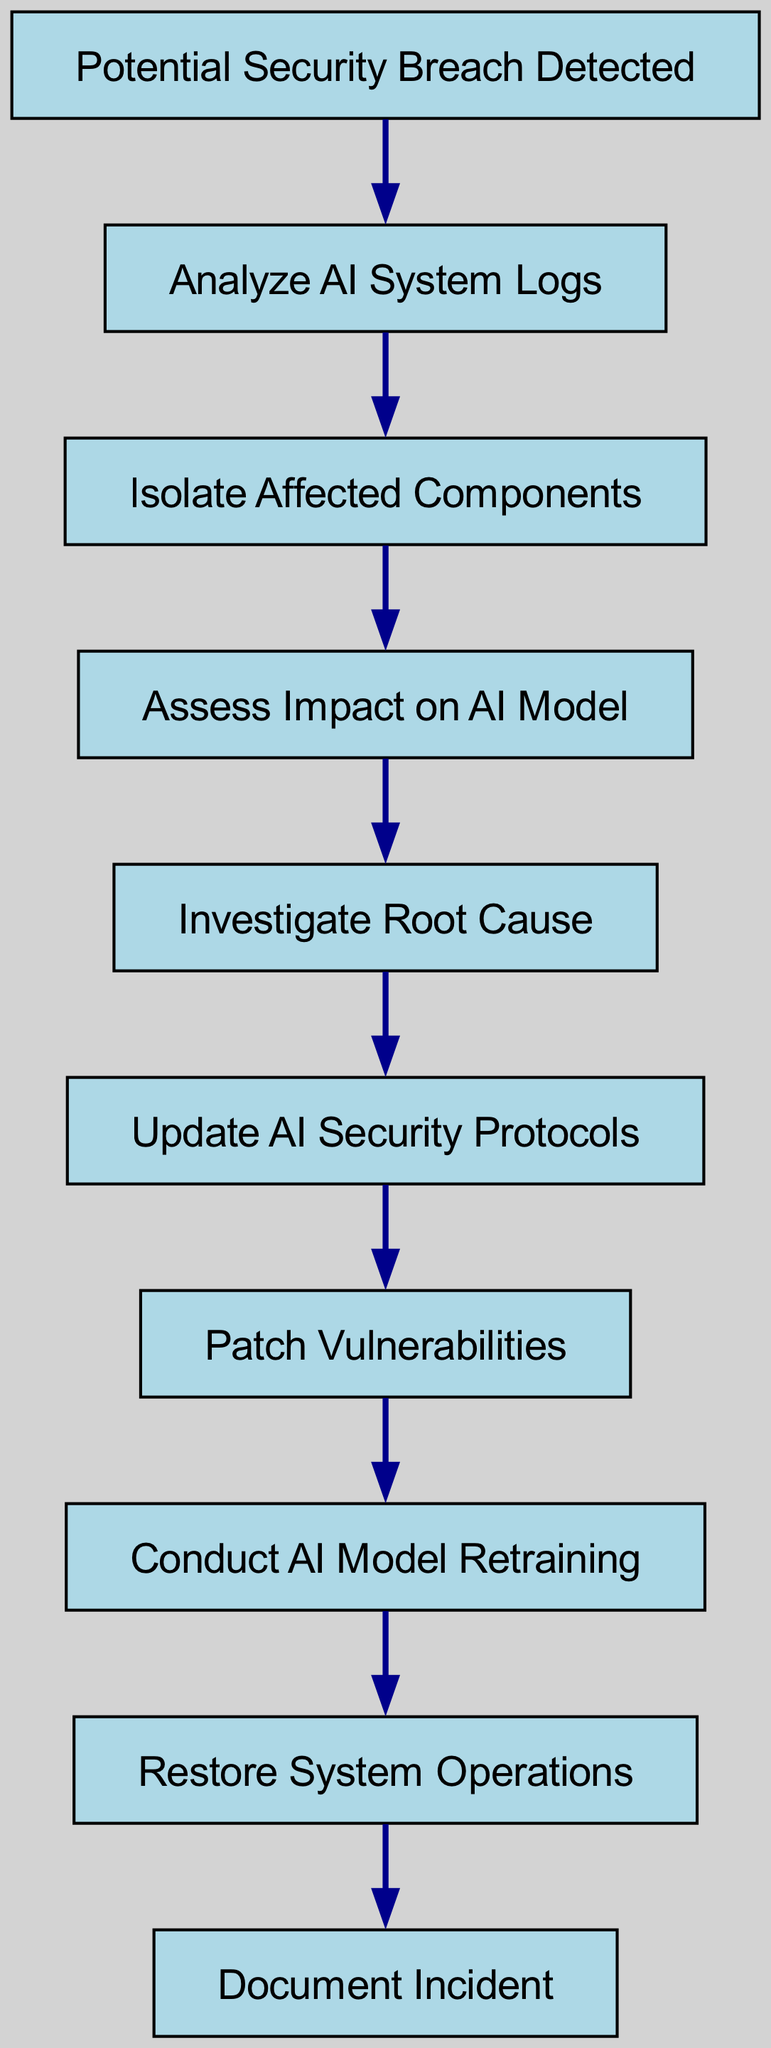What is the starting node in the diagram? The starting node is explicitly mentioned as "Potential Security Breach Detected," which initiates the workflow.
Answer: Potential Security Breach Detected How many nodes are present in the diagram? By counting the nodes listed, which include the starting node and subsequent steps, there are a total of nine distinct nodes in the workflow.
Answer: 9 What is the last step in the incident response workflow? The final node in the sequence is "Document Incident," which indicates the last action to take after restoring system operations.
Answer: Document Incident What comes immediately after "Investigate Root Cause"? Following "Investigate Root Cause," the next step in the workflow is "Update AI Security Protocols," which signifies the necessary response after investigating the breach's cause.
Answer: Update AI Security Protocols Is "Patch Vulnerabilities" directly connected to "Assess Impact on AI Model"? No, "Patch Vulnerabilities" is not directly connected to "Assess Impact on AI Model"; instead, it follows "Update AI Security Protocols," indicating that patching occurs after updating the security protocols.
Answer: No What is the third node in the sequence? The sequence progresses from the starting node to "Analyze AI System Logs," then to "Isolate Affected Components," and finally to "Assess Impact on AI Model," making the third node "Assess Impact on AI Model."
Answer: Assess Impact on AI Model What are the two nodes connected to "Conduct AI Model Retraining"? The nodes directly connected to "Conduct AI Model Retraining" are "Patch Vulnerabilities" before it and "Restore System Operations" after it, indicating the workflow's flow before and after this step.
Answer: Patch Vulnerabilities, Restore System Operations How many edges are in the diagram? The edges represent the connections between the nodes, and by tallying them, there are a total of eight edges present that define the flow of the diagram.
Answer: 8 Which step is taken immediately after "Isolate Affected Components"? The following step in the workflow after "Isolate Affected Components" is "Assess Impact on AI Model," which implies assessing the implications of the isolation before proceeding further.
Answer: Assess Impact on AI Model 